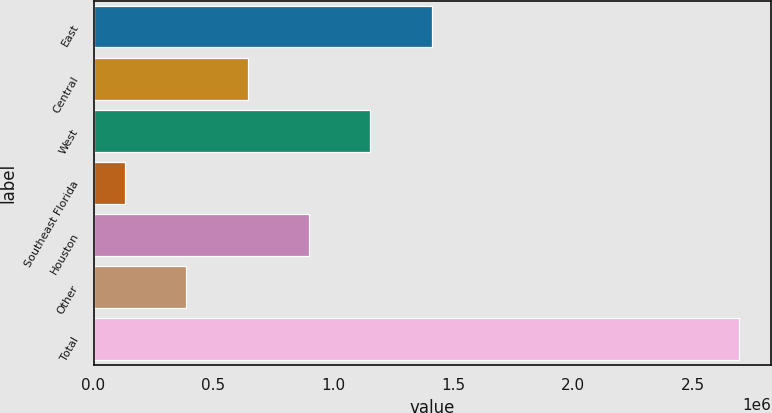<chart> <loc_0><loc_0><loc_500><loc_500><bar_chart><fcel>East<fcel>Central<fcel>West<fcel>Southeast Florida<fcel>Houston<fcel>Other<fcel>Total<nl><fcel>1.41169e+06<fcel>643331<fcel>1.15557e+06<fcel>131091<fcel>899451<fcel>387211<fcel>2.69229e+06<nl></chart> 